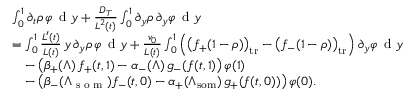Convert formula to latex. <formula><loc_0><loc_0><loc_500><loc_500>\begin{array} { r l } & { \int _ { 0 } ^ { 1 } \partial _ { t } \rho \, \varphi \, d y + \frac { D _ { T } } { L ^ { 2 } ( t ) } \int _ { 0 } ^ { 1 } \partial _ { y } \rho \, \partial _ { y } \varphi \, d y } \\ & { = \int _ { 0 } ^ { 1 } \frac { L ^ { \prime } ( t ) } { L ( t ) } \, y \, \partial _ { y } \rho \, \varphi \, d y + \frac { v _ { 0 } } { L ( t ) } \int _ { 0 } ^ { 1 } \left ( \left ( f _ { + } ( 1 - \rho ) \right ) _ { t r } - \left ( f _ { - } ( 1 - \rho ) \right ) _ { t r } \right ) \partial _ { y } \varphi \, d y } \\ & { \quad - \left ( \beta _ { + } ( \Lambda ) \, f _ { + } ( t , 1 ) - \alpha _ { - } ( \Lambda ) \, g _ { - } ( f ( t , 1 ) \right ) \varphi ( 1 ) } \\ & { \quad - \left ( \beta _ { - } ( \Lambda _ { s o m } ) f _ { - } ( t , 0 ) - \alpha _ { + } ( \Lambda _ { s o m } ) \, g _ { + } ( f ( t , 0 ) ) \right ) \varphi ( 0 ) . } \end{array}</formula> 